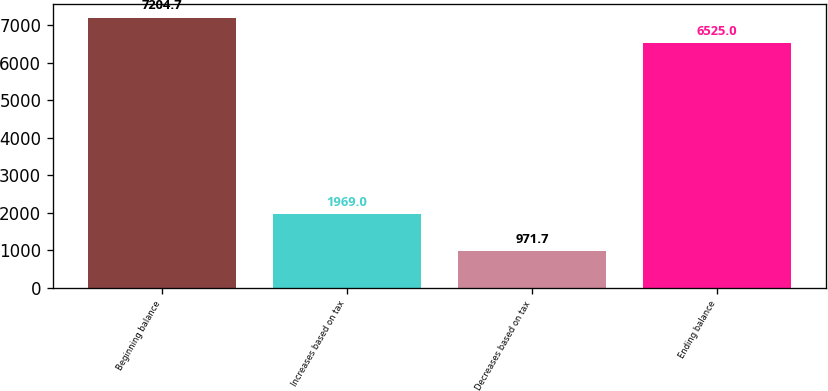<chart> <loc_0><loc_0><loc_500><loc_500><bar_chart><fcel>Beginning balance<fcel>Increases based on tax<fcel>Decreases based on tax<fcel>Ending balance<nl><fcel>7204.7<fcel>1969<fcel>971.7<fcel>6525<nl></chart> 